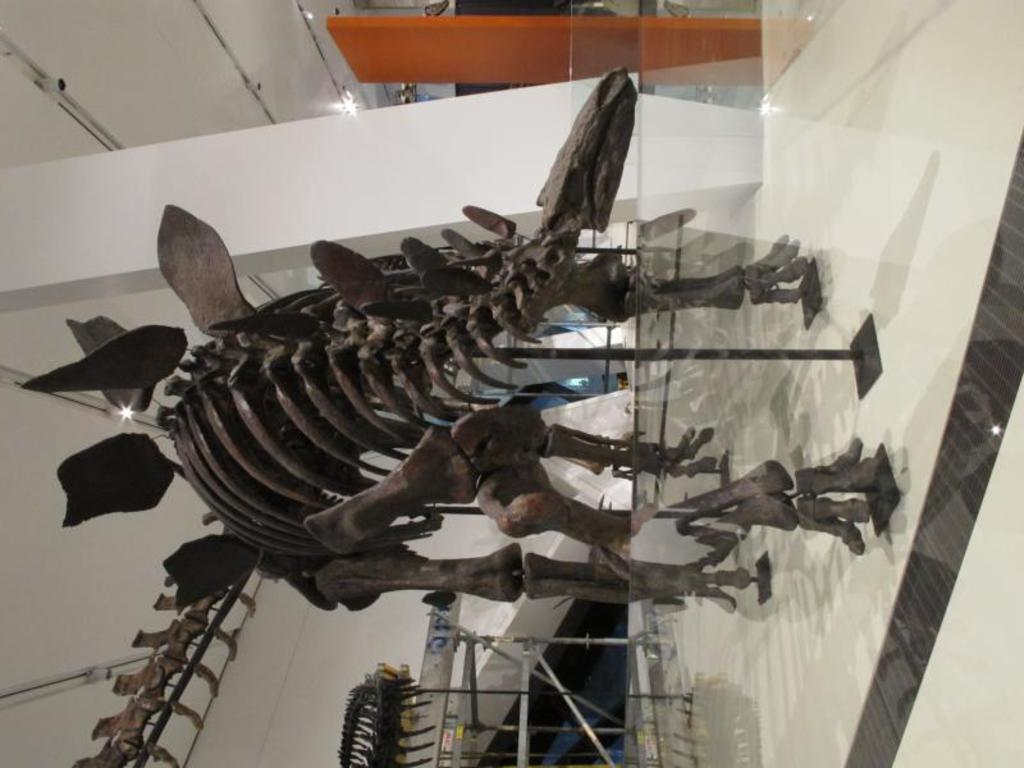What type of structure is present in the image? There is a wall in the image. What piece of furniture can be seen in the image? There is a table in the image. What type of illumination is present in the image? There are lights in the image. What type of flooring is present in the image? There are white color tiles in the image. What unusual object is present in the image? There is an animal skeleton in the image. What type of drink is being served in the image? There is no drink present in the image. What type of collar is visible on the animal skeleton in the image? There is no collar present on the animal skeleton in the image, as it is a skeleton and not a living animal. 